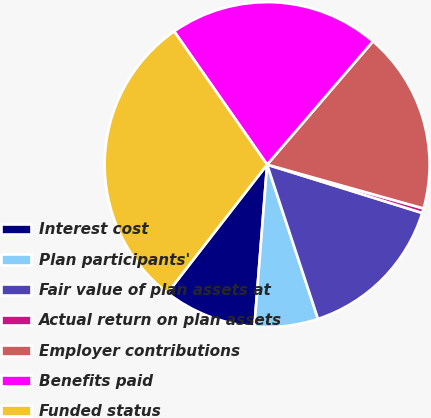Convert chart. <chart><loc_0><loc_0><loc_500><loc_500><pie_chart><fcel>Interest cost<fcel>Plan participants'<fcel>Fair value of plan assets at<fcel>Actual return on plan assets<fcel>Employer contributions<fcel>Benefits paid<fcel>Funded status<nl><fcel>9.26%<fcel>6.32%<fcel>15.12%<fcel>0.46%<fcel>18.06%<fcel>20.99%<fcel>29.8%<nl></chart> 